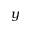Convert formula to latex. <formula><loc_0><loc_0><loc_500><loc_500>y</formula> 